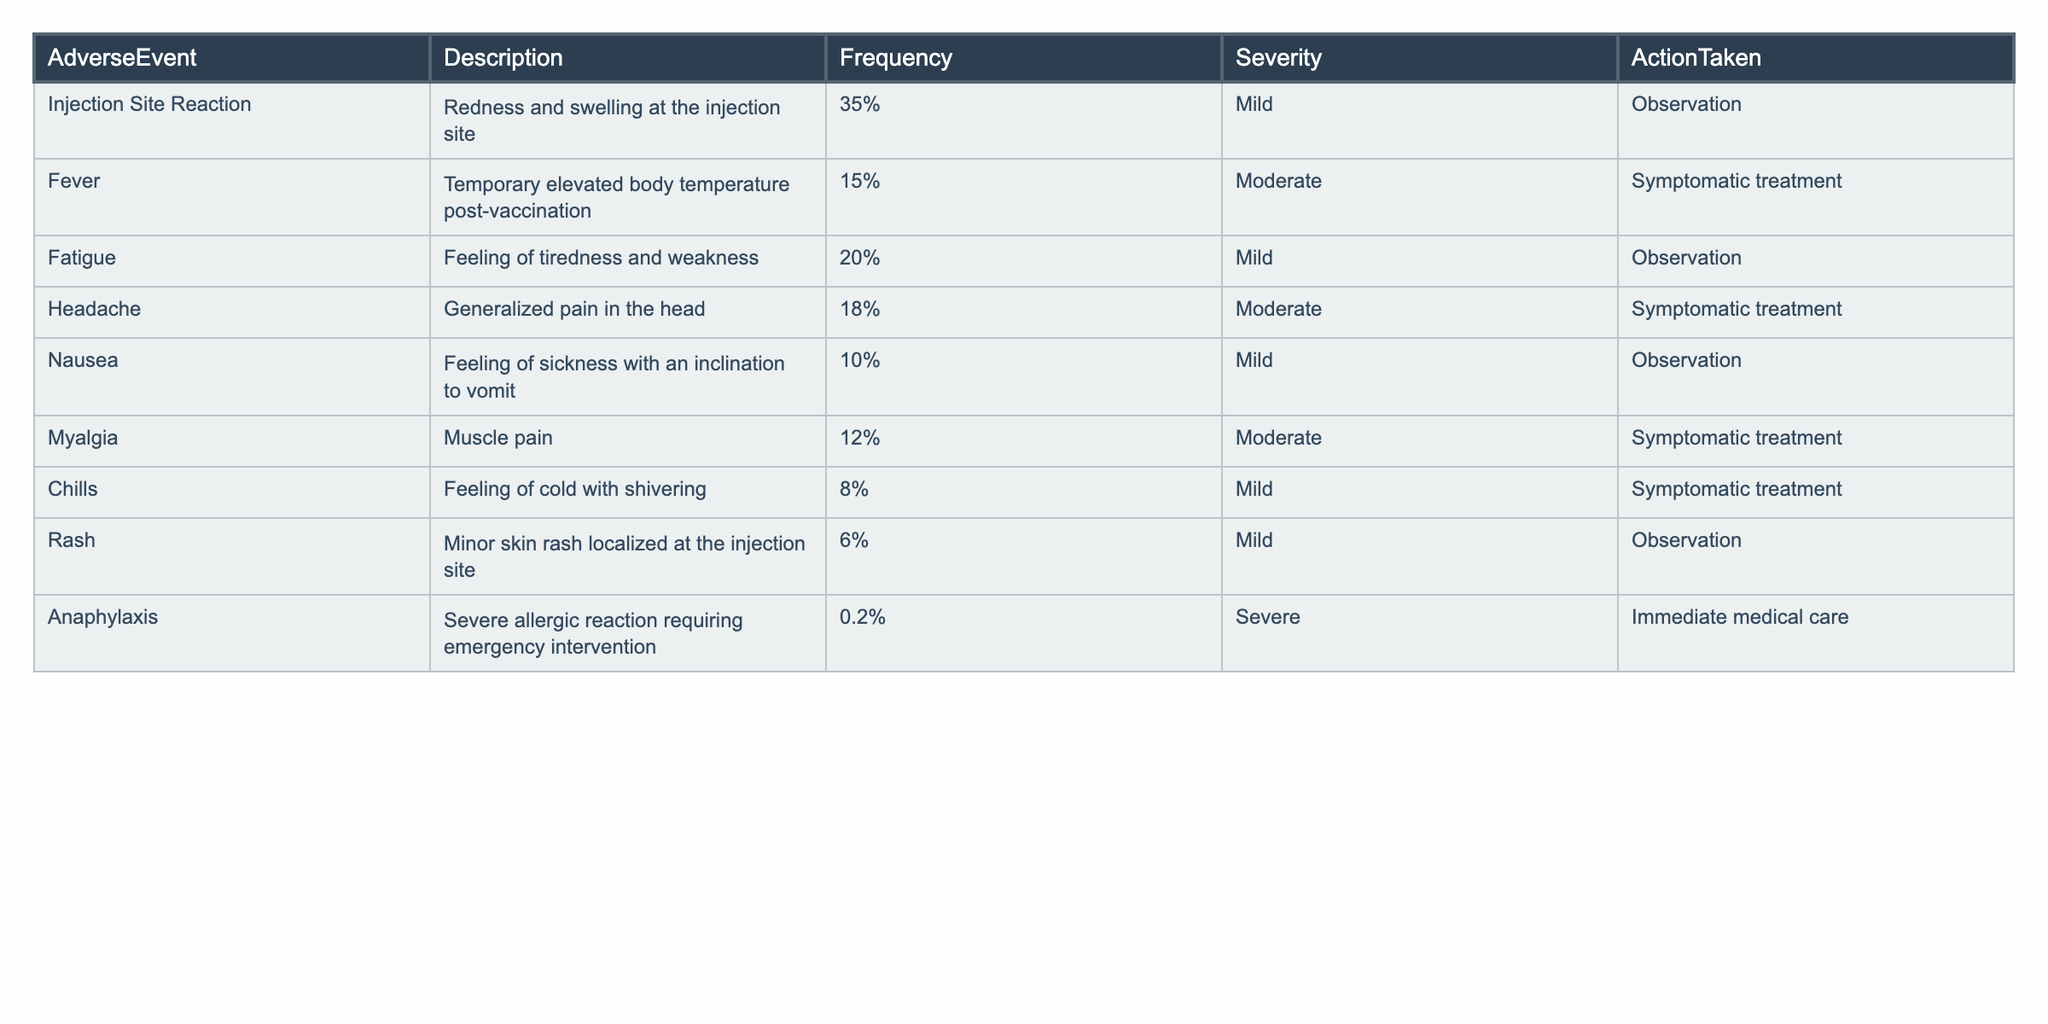What is the frequency of fever as an adverse event? The frequency of fever is listed directly in the table under the Frequency column, which shows 15%.
Answer: 15% What action is taken for anaphylaxis? The table specifies that for anaphylaxis, the action taken is "Immediate medical care".
Answer: Immediate medical care Which adverse event has the highest frequency? The event with the highest frequency is "Injection Site Reaction," which has a frequency of 35%.
Answer: Injection Site Reaction What percentage of adverse events reported are classified as mild severity? There are four adverse events classified as mild: Injection Site Reaction (35%), Fatigue (20%), Nausea (10%), and Chills (8%). Adding these, we find 73%.
Answer: 73% How many adverse events have a frequency below 10%? The relevant events with frequency below 10% are "Chills" (8%) and "Rash" (6%), which totals two events.
Answer: 2 Is the frequency of myalgia higher than that of nausea? The frequency of myalgia is 12% and the frequency of nausea is 10%. Since 12% is greater than 10%, myalgia's frequency is indeed higher.
Answer: Yes What is the average frequency of moderate adverse events? The events classified as moderate are Fever (15%), Headache (18%), and Myalgia (12%). To find the average: (15 + 18 + 12) / 3 = 15%.
Answer: 15% What adverse event requires symptomatic treatment the most? The events requiring symptomatic treatment are Fever (15%), Headache (18%), Myalgia (12%), and Chills (8%). Among these, Headache has the highest frequency at 18%.
Answer: Headache If we consider only severe adverse events, how many are reported in the data? The table indicates that only one severe event is reported, which is anaphylaxis.
Answer: 1 What is the difference in frequency between the most common and least common adverse events? The most common event is Injection Site Reaction at 35% and the least common is Anaphylaxis at 0.2%. The difference is 35% - 0.2% = 34.8%.
Answer: 34.8% 